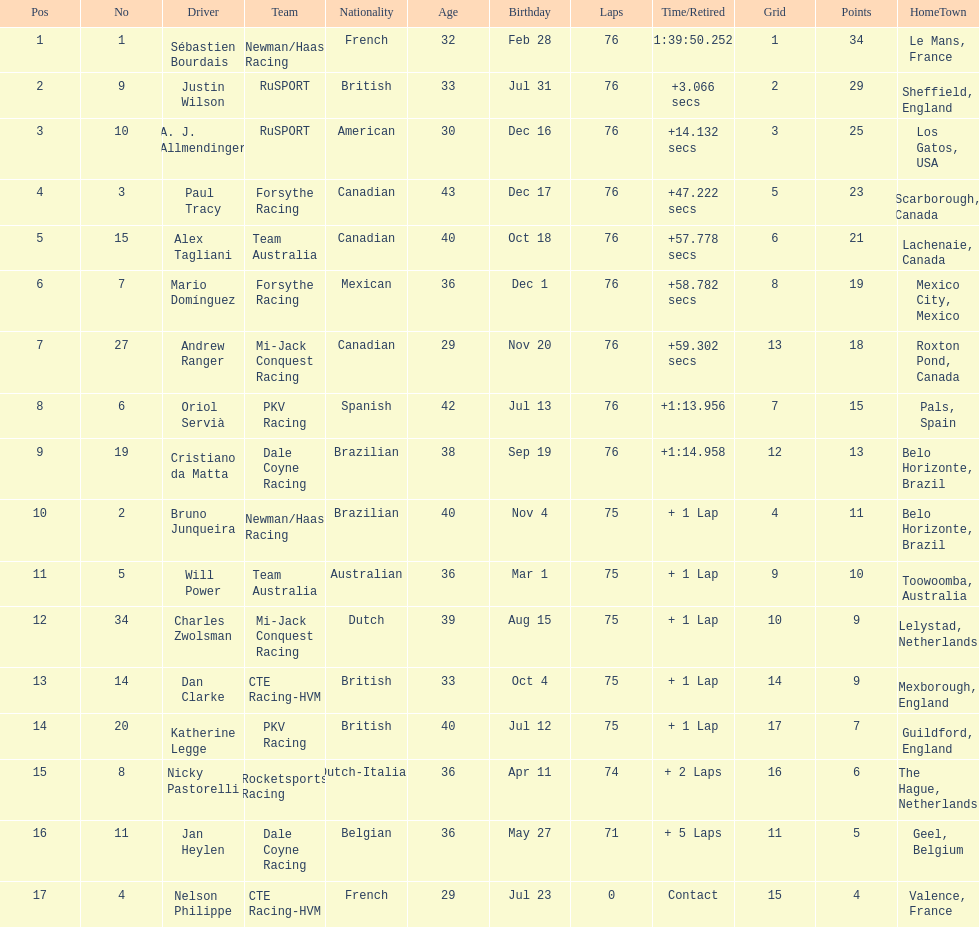Which driver earned the least amount of points. Nelson Philippe. 